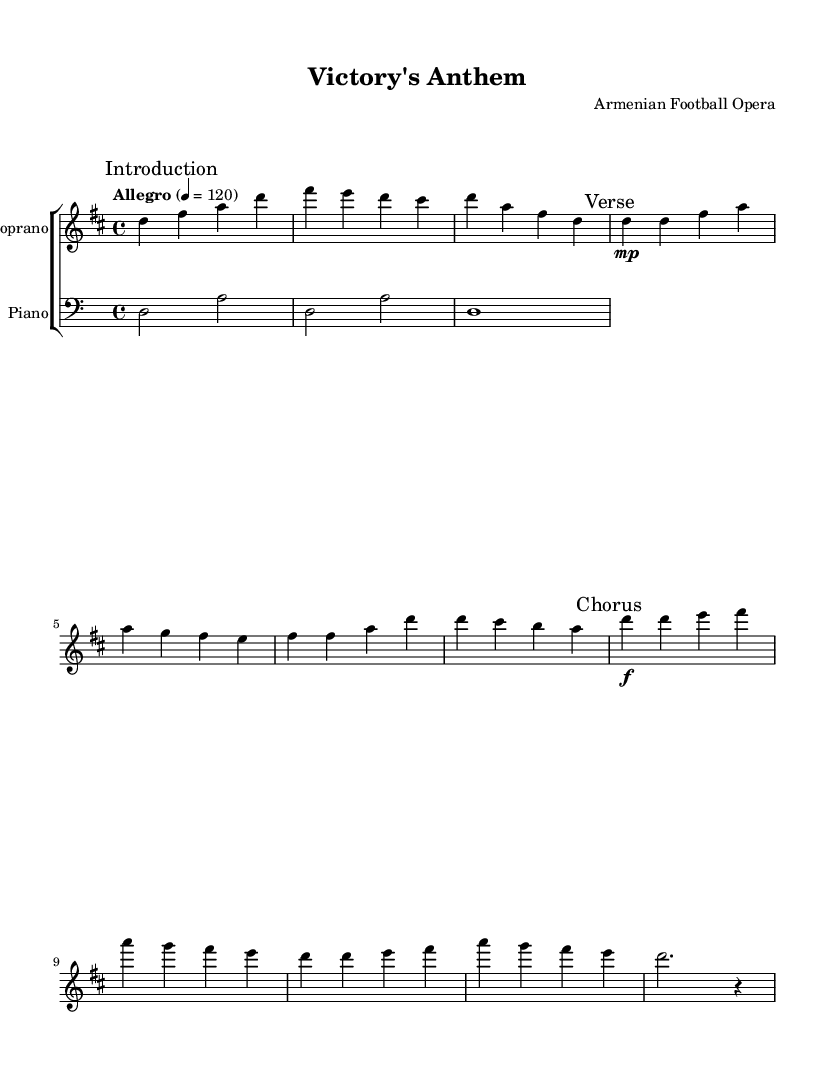What is the key signature of this music? The key signature is indicated at the beginning of the music. In this case, it shows two sharps, which is characteristic of D major.
Answer: D major What is the time signature of this music? The time signature is displayed at the beginning in the measure signature. Here it shows 4/4, meaning there are four beats in a measure, and a quarter note gets one beat.
Answer: 4/4 What is the tempo marking of this piece? The tempo marking is found at the start and indicates how fast the piece should be played. It states "Allegro" with a tempo of 120 beats per minute.
Answer: Allegro What is the dynamic marking during the Verse section? The Verse section has a dynamic marking that indicates the volume level for performance. It indicates "mp," which stands for mezzo-piano, meaning moderately soft.
Answer: mp How many times is the word "together" mentioned in the lyrics? By examining the lyrics under the soprano voice part, you can count how many times "together" appears. It is mentioned once in the chorus section.
Answer: Once What type of ensemble is indicated in the score? The score represents a choir with various parts showcasing a soprano, tenor, and bass, as indicated by the *ChoirStaff*.
Answer: Choir What thematic elements are prominent in the lyrics? The lyrics emphasize themes of unity and perseverance, depicting the spirit of fighting together for victory. This is evident in phrases such as "United we stand" and "Together we fight."
Answer: Unity and perseverance 